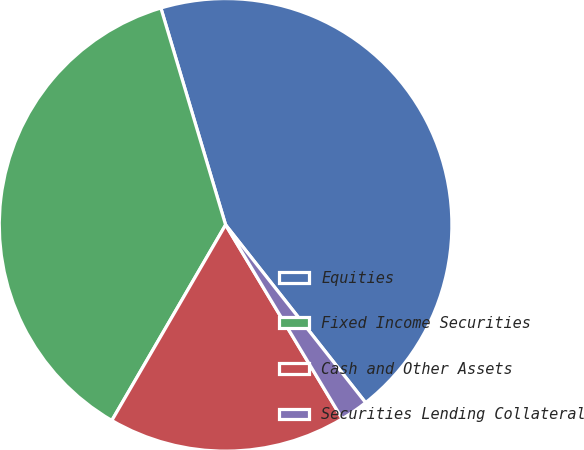Convert chart. <chart><loc_0><loc_0><loc_500><loc_500><pie_chart><fcel>Equities<fcel>Fixed Income Securities<fcel>Cash and Other Assets<fcel>Securities Lending Collateral<nl><fcel>44.0%<fcel>37.0%<fcel>17.0%<fcel>2.0%<nl></chart> 